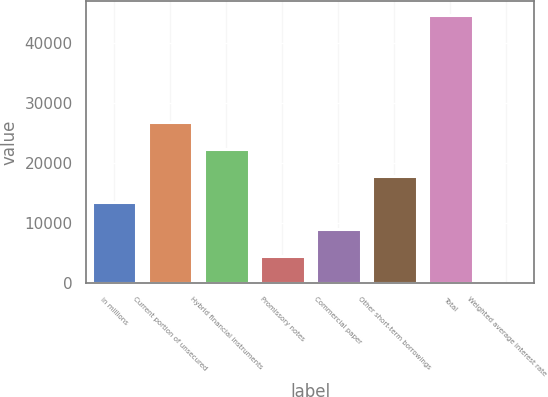Convert chart to OTSL. <chart><loc_0><loc_0><loc_500><loc_500><bar_chart><fcel>in millions<fcel>Current portion of unsecured<fcel>Hybrid financial instruments<fcel>Promissory notes<fcel>Commercial paper<fcel>Other short-term borrowings<fcel>Total<fcel>Weighted average interest rate<nl><fcel>13408.8<fcel>26815.8<fcel>22346.8<fcel>4470.68<fcel>8939.72<fcel>17877.8<fcel>44692<fcel>1.65<nl></chart> 